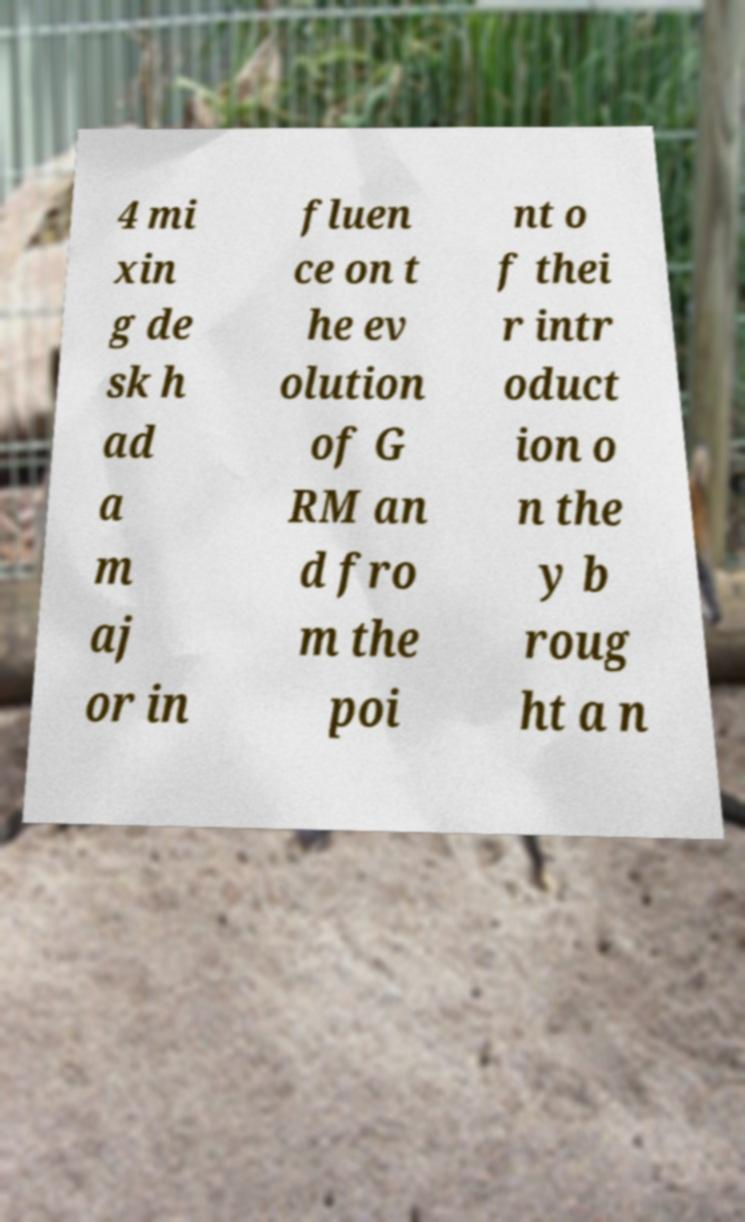There's text embedded in this image that I need extracted. Can you transcribe it verbatim? 4 mi xin g de sk h ad a m aj or in fluen ce on t he ev olution of G RM an d fro m the poi nt o f thei r intr oduct ion o n the y b roug ht a n 